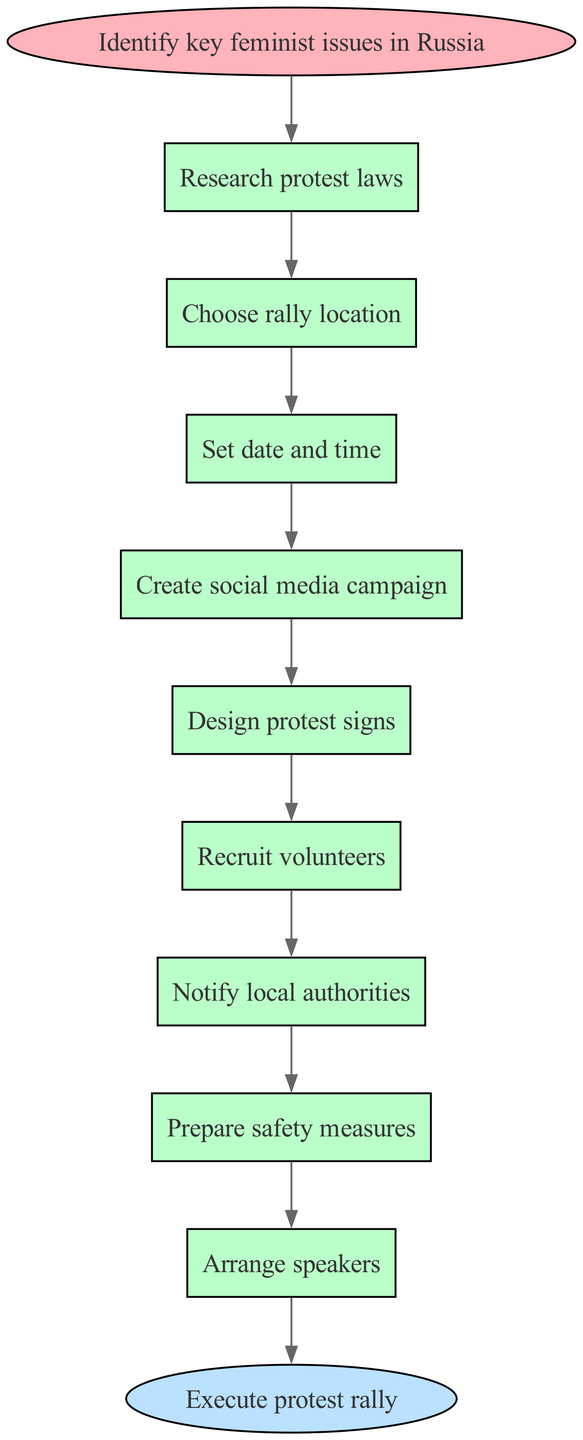What is the first step in organizing a feminist protest rally? The first step is shown as the starting point in the diagram, labeled "Identify key feminist issues in Russia," indicating it's the initial action required for the rally organization.
Answer: Identify key feminist issues in Russia How many nodes are in the diagram? The diagram includes the start node, the end node, and eight process nodes, totaling ten nodes. Therefore, counting all, there are ten nodes in total.
Answer: 10 What is the last step before executing the protest rally? The last step before reaching the end of the flowchart is indicated as "Arrange speakers," which is the final action to be completed directly before executing the protest rally.
Answer: Arrange speakers What is the relationship between "Notify local authorities" and "Prepare safety measures"? The flowchart specifies a directional connection (an edge) indicating that "Notify local authorities" leads to "Prepare safety measures," showing that notifying authorities is a prerequisite for preparing safety measures.
Answer: Notify local authorities leads to Prepare safety measures How many edges are there in total? By counting from the diagram, there are eight edges connecting the various nodes, along with one edge from the start node to the first process node, making a total of nine edges.
Answer: 9 Which step comes after "Design protest signs"? According to the flowchart structure, "Recruit volunteers" follows "Design protest signs," indicating this is the subsequent action workers should take after creating the signs.
Answer: Recruit volunteers What phase does the rally organization start from? The organization process begins with the specified phase "Identify key feminist issues in Russia," which is the initial action taken in the flowchart for organizing the rally.
Answer: Identify key feminist issues in Russia How many actions are directly involved in the process nodes? The process nodes in the diagram display a total of eight specific actions, which comprise the series of steps needed to organize the rally effectively, excluding the start and end nodes.
Answer: 8 